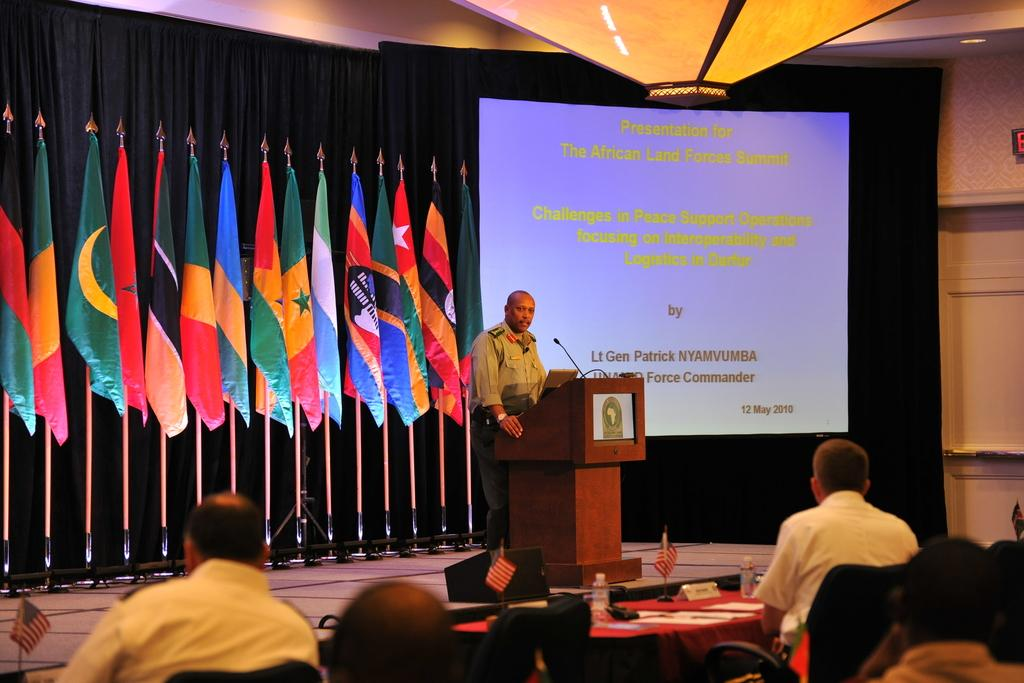What is the man in the image doing? The man is standing in front of the podium. What is the man holding in the image? The man is holding a microphone. What can be seen in the background of the image? There is a screen, a flag, and a curtain in the background. How many sisters are standing next to the man in the image? There are no sisters present in the image. What type of umbrella is being used by the beggar in the image? There is no beggar or umbrella present in the image. 